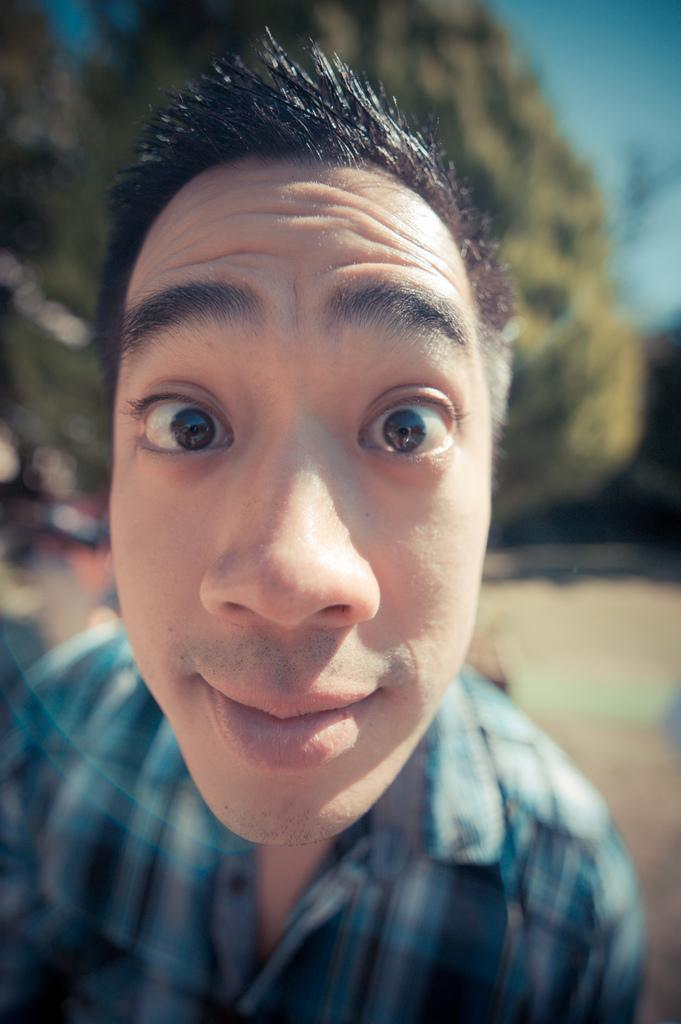Who is present in the image? There is a man in the image. What is the man doing in the image? The man is standing in the image. What is the man wearing in the image? The man is wearing a blue checkered shirt in the image. What natural elements can be seen in the image? There is a tree and the sky visible in the image. What type of chin is visible on the man in the image? There is no chin visible on the man in the image, as the image only shows the man from the chest up. 